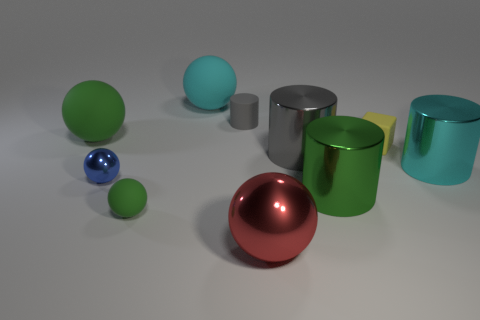Subtract all red balls. How many balls are left? 4 Subtract 2 spheres. How many spheres are left? 3 Subtract all big red shiny balls. How many balls are left? 4 Subtract all purple cylinders. Subtract all blue blocks. How many cylinders are left? 4 Subtract all cylinders. How many objects are left? 6 Subtract 1 yellow cubes. How many objects are left? 9 Subtract all large blue matte spheres. Subtract all shiny cylinders. How many objects are left? 7 Add 3 tiny metal objects. How many tiny metal objects are left? 4 Add 9 green blocks. How many green blocks exist? 9 